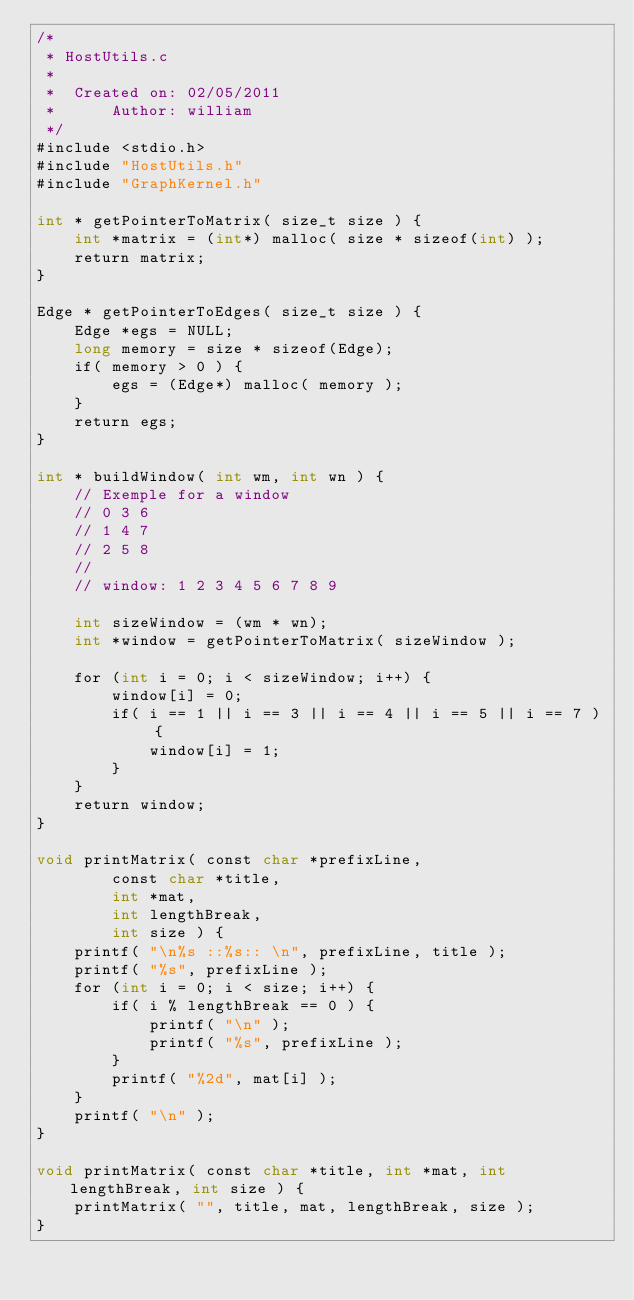Convert code to text. <code><loc_0><loc_0><loc_500><loc_500><_Cuda_>/*
 * HostUtils.c
 *
 *  Created on: 02/05/2011
 *      Author: william
 */
#include <stdio.h>
#include "HostUtils.h"
#include "GraphKernel.h"

int * getPointerToMatrix( size_t size ) {
	int *matrix = (int*) malloc( size * sizeof(int) );
	return matrix;
}

Edge * getPointerToEdges( size_t size ) {
	Edge *egs = NULL;
	long memory = size * sizeof(Edge);
	if( memory > 0 ) {
		egs = (Edge*) malloc( memory );
	}
	return egs;
}

int * buildWindow( int wm, int wn ) {
	// Exemple for a window
	// 0 3 6
	// 1 4 7
	// 2 5 8
	//
	// window: 1 2 3 4 5 6 7 8 9

	int sizeWindow = (wm * wn);
	int *window = getPointerToMatrix( sizeWindow );

	for (int i = 0; i < sizeWindow; i++) {
		window[i] = 0;
		if( i == 1 || i == 3 || i == 4 || i == 5 || i == 7 ) {
			window[i] = 1;
		}
	}
	return window;
}

void printMatrix( const char *prefixLine,
		const char *title,
		int *mat,
		int lengthBreak,
		int size ) {
	printf( "\n%s ::%s:: \n", prefixLine, title );
	printf( "%s", prefixLine );
	for (int i = 0; i < size; i++) {
		if( i % lengthBreak == 0 ) {
			printf( "\n" );
			printf( "%s", prefixLine );
		}
		printf( "%2d", mat[i] );
	}
	printf( "\n" );
}

void printMatrix( const char *title, int *mat, int lengthBreak, int size ) {
	printMatrix( "", title, mat, lengthBreak, size );
}
</code> 